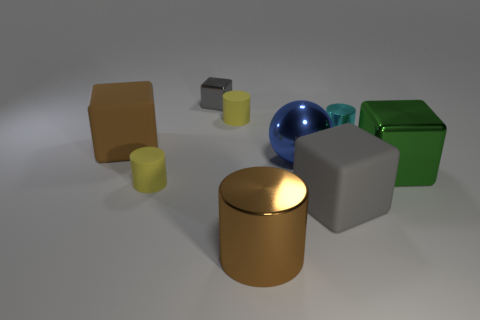How many large green shiny balls are there?
Your answer should be very brief. 0. Are there any other things that have the same size as the brown metallic thing?
Offer a very short reply. Yes. Is the brown cylinder made of the same material as the tiny cyan object?
Your answer should be compact. Yes. Does the yellow object that is behind the cyan cylinder have the same size as the metallic cylinder to the right of the blue metallic sphere?
Provide a succinct answer. Yes. Is the number of cyan shiny cylinders less than the number of tiny yellow matte objects?
Your answer should be compact. Yes. What number of metallic objects are either yellow objects or tiny cylinders?
Provide a succinct answer. 1. There is a metal object that is in front of the big gray matte thing; is there a tiny yellow thing behind it?
Provide a succinct answer. Yes. Are the yellow cylinder in front of the large blue thing and the blue object made of the same material?
Your answer should be compact. No. How many other things are there of the same color as the large shiny ball?
Keep it short and to the point. 0. Is the tiny block the same color as the metal sphere?
Keep it short and to the point. No. 